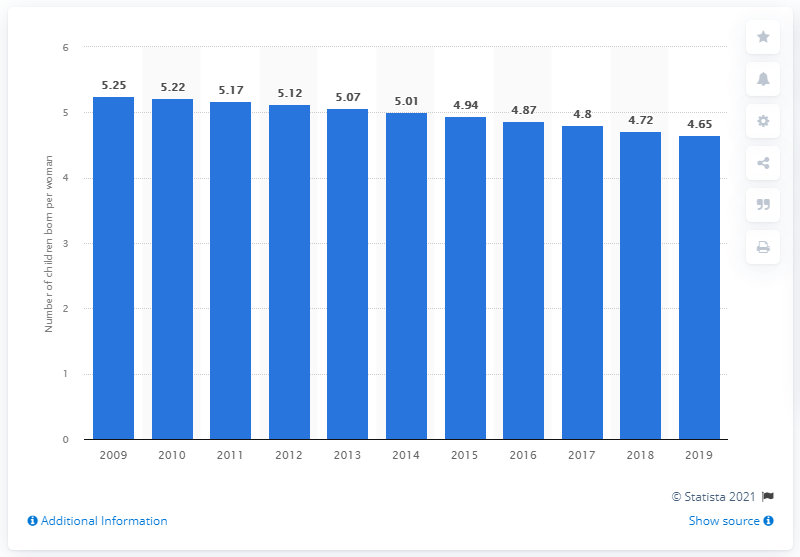Specify some key components in this picture. In 2019, the fertility rate in the Central African Republic was 4.65. 